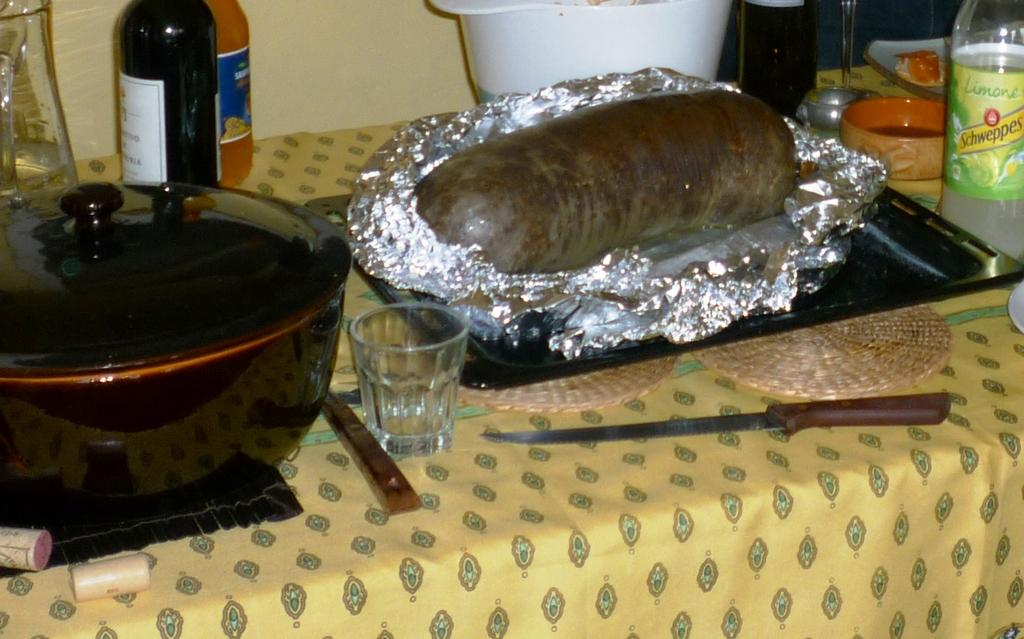<image>
Offer a succinct explanation of the picture presented. a bottle ofSchweppes next to a giant sausage on a table 